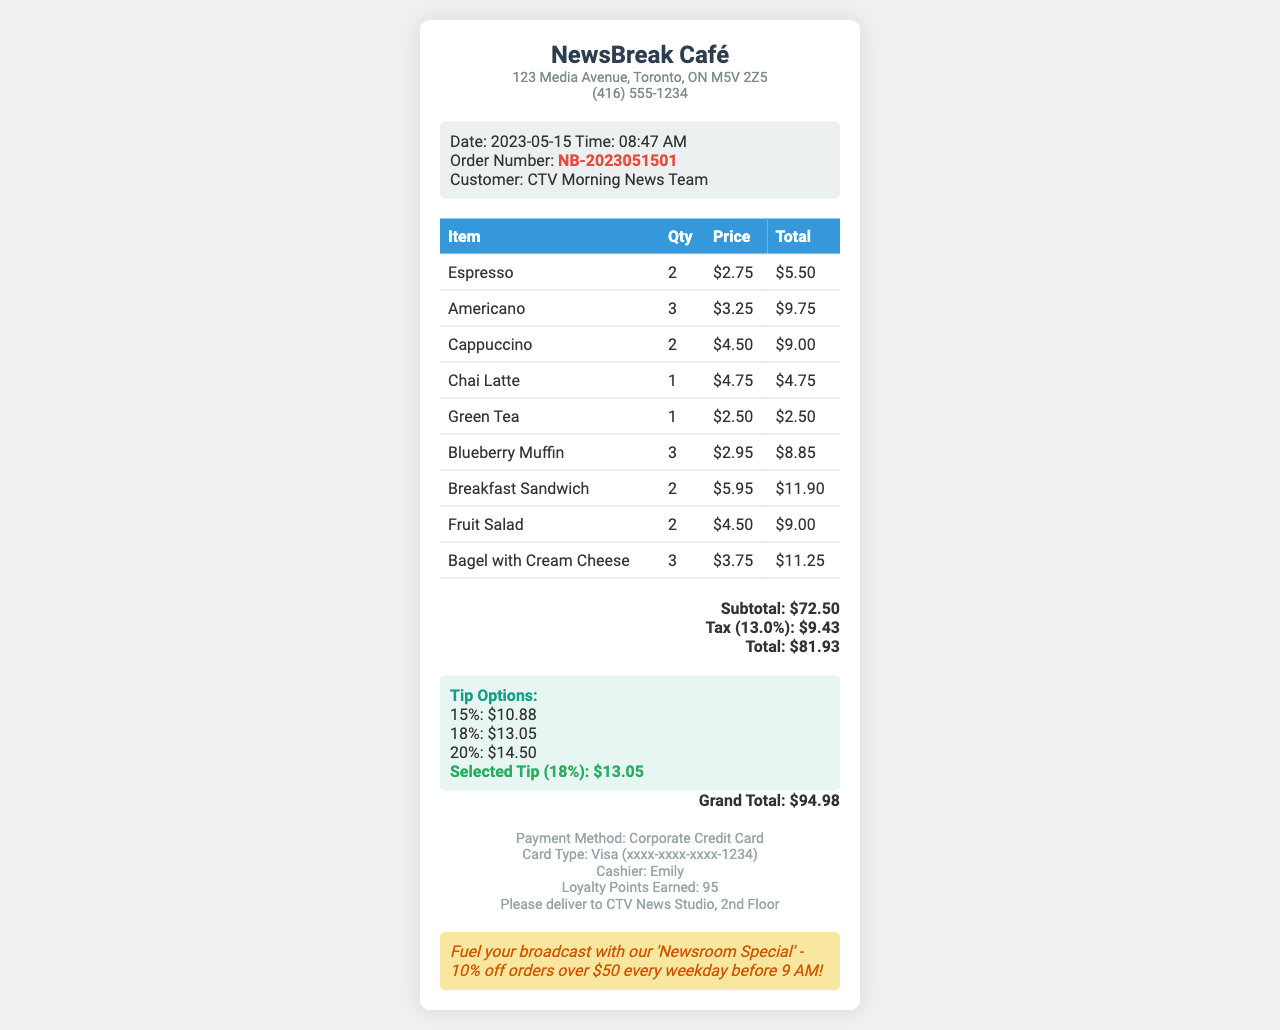What is the store name? The store name is prominently displayed at the top of the receipt.
Answer: NewsBreak Café What is the total amount of the order before tax? The subtotal is listed on the receipt before tax is added.
Answer: $72.50 How much tax was charged? The tax amount is specified as a separate line on the receipt.
Answer: $9.43 What was the selected tip percentage? The selected tip percentage is mentioned in the tip options section.
Answer: 18% What is the grand total after including the tip? The grand total reflects the total cost including the tip, summing all previous values.
Answer: $94.98 Who was the cashier for the transaction? The cashier's name is mentioned towards the bottom of the receipt.
Answer: Emily What special instructions were given for the order? Special instructions are noted in a section towards the end of the document.
Answer: Please deliver to CTV News Studio, 2nd Floor How many loyalty points were earned from this order? The earned loyalty points are stated clearly at the bottom of the receipt.
Answer: 95 How many Blueberry Muffins were ordered? The quantity of specific items ordered is detailed in the table of items.
Answer: 3 